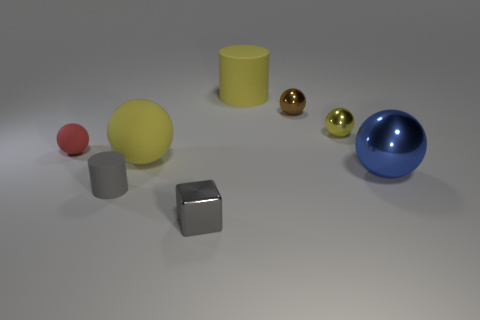Are the tiny red object and the tiny gray cylinder made of the same material?
Make the answer very short. Yes. What number of rubber things are cylinders or tiny red cubes?
Provide a succinct answer. 2. What color is the matte cylinder that is the same size as the brown object?
Ensure brevity in your answer.  Gray. How many large blue shiny things are the same shape as the yellow metallic object?
Offer a very short reply. 1. How many cylinders are either purple shiny objects or big metallic objects?
Offer a terse response. 0. There is a small gray object that is to the right of the large yellow matte sphere; is it the same shape as the large matte object that is in front of the red rubber thing?
Provide a short and direct response. No. What is the yellow cylinder made of?
Your answer should be compact. Rubber. The matte object that is the same color as the large cylinder is what shape?
Offer a terse response. Sphere. What number of yellow rubber objects are the same size as the red matte ball?
Ensure brevity in your answer.  0. What number of objects are either red things left of the large blue metal ball or things left of the brown thing?
Your response must be concise. 5. 